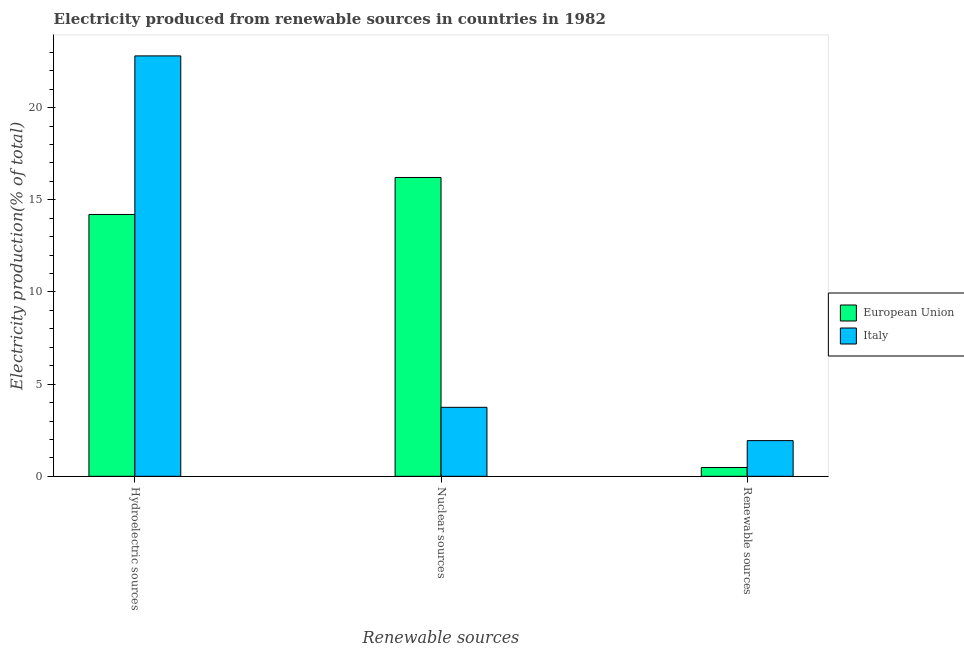How many groups of bars are there?
Give a very brief answer. 3. How many bars are there on the 2nd tick from the left?
Offer a very short reply. 2. How many bars are there on the 1st tick from the right?
Provide a short and direct response. 2. What is the label of the 2nd group of bars from the left?
Your answer should be very brief. Nuclear sources. What is the percentage of electricity produced by nuclear sources in European Union?
Make the answer very short. 16.21. Across all countries, what is the maximum percentage of electricity produced by nuclear sources?
Provide a succinct answer. 16.21. Across all countries, what is the minimum percentage of electricity produced by hydroelectric sources?
Offer a very short reply. 14.2. In which country was the percentage of electricity produced by hydroelectric sources maximum?
Offer a very short reply. Italy. What is the total percentage of electricity produced by hydroelectric sources in the graph?
Keep it short and to the point. 37.01. What is the difference between the percentage of electricity produced by renewable sources in European Union and that in Italy?
Keep it short and to the point. -1.46. What is the difference between the percentage of electricity produced by nuclear sources in Italy and the percentage of electricity produced by renewable sources in European Union?
Provide a short and direct response. 3.26. What is the average percentage of electricity produced by nuclear sources per country?
Provide a short and direct response. 9.98. What is the difference between the percentage of electricity produced by hydroelectric sources and percentage of electricity produced by renewable sources in Italy?
Keep it short and to the point. 20.87. In how many countries, is the percentage of electricity produced by hydroelectric sources greater than 2 %?
Your answer should be compact. 2. What is the ratio of the percentage of electricity produced by hydroelectric sources in European Union to that in Italy?
Make the answer very short. 0.62. Is the percentage of electricity produced by nuclear sources in European Union less than that in Italy?
Ensure brevity in your answer.  No. What is the difference between the highest and the second highest percentage of electricity produced by hydroelectric sources?
Ensure brevity in your answer.  8.6. What is the difference between the highest and the lowest percentage of electricity produced by nuclear sources?
Ensure brevity in your answer.  12.47. In how many countries, is the percentage of electricity produced by renewable sources greater than the average percentage of electricity produced by renewable sources taken over all countries?
Offer a terse response. 1. What does the 2nd bar from the left in Hydroelectric sources represents?
Keep it short and to the point. Italy. What does the 1st bar from the right in Renewable sources represents?
Your response must be concise. Italy. Is it the case that in every country, the sum of the percentage of electricity produced by hydroelectric sources and percentage of electricity produced by nuclear sources is greater than the percentage of electricity produced by renewable sources?
Your response must be concise. Yes. How many countries are there in the graph?
Provide a short and direct response. 2. What is the difference between two consecutive major ticks on the Y-axis?
Ensure brevity in your answer.  5. Does the graph contain grids?
Provide a short and direct response. No. What is the title of the graph?
Give a very brief answer. Electricity produced from renewable sources in countries in 1982. Does "Sudan" appear as one of the legend labels in the graph?
Offer a terse response. No. What is the label or title of the X-axis?
Provide a succinct answer. Renewable sources. What is the Electricity production(% of total) of European Union in Hydroelectric sources?
Offer a very short reply. 14.2. What is the Electricity production(% of total) in Italy in Hydroelectric sources?
Your response must be concise. 22.8. What is the Electricity production(% of total) in European Union in Nuclear sources?
Keep it short and to the point. 16.21. What is the Electricity production(% of total) of Italy in Nuclear sources?
Provide a short and direct response. 3.74. What is the Electricity production(% of total) of European Union in Renewable sources?
Offer a very short reply. 0.48. What is the Electricity production(% of total) in Italy in Renewable sources?
Give a very brief answer. 1.94. Across all Renewable sources, what is the maximum Electricity production(% of total) of European Union?
Offer a very short reply. 16.21. Across all Renewable sources, what is the maximum Electricity production(% of total) of Italy?
Your answer should be very brief. 22.8. Across all Renewable sources, what is the minimum Electricity production(% of total) of European Union?
Provide a succinct answer. 0.48. Across all Renewable sources, what is the minimum Electricity production(% of total) of Italy?
Your response must be concise. 1.94. What is the total Electricity production(% of total) in European Union in the graph?
Your answer should be very brief. 30.89. What is the total Electricity production(% of total) of Italy in the graph?
Your response must be concise. 28.48. What is the difference between the Electricity production(% of total) of European Union in Hydroelectric sources and that in Nuclear sources?
Your response must be concise. -2.01. What is the difference between the Electricity production(% of total) of Italy in Hydroelectric sources and that in Nuclear sources?
Give a very brief answer. 19.06. What is the difference between the Electricity production(% of total) in European Union in Hydroelectric sources and that in Renewable sources?
Provide a short and direct response. 13.72. What is the difference between the Electricity production(% of total) in Italy in Hydroelectric sources and that in Renewable sources?
Make the answer very short. 20.87. What is the difference between the Electricity production(% of total) in European Union in Nuclear sources and that in Renewable sources?
Ensure brevity in your answer.  15.73. What is the difference between the Electricity production(% of total) of Italy in Nuclear sources and that in Renewable sources?
Provide a succinct answer. 1.81. What is the difference between the Electricity production(% of total) in European Union in Hydroelectric sources and the Electricity production(% of total) in Italy in Nuclear sources?
Ensure brevity in your answer.  10.46. What is the difference between the Electricity production(% of total) in European Union in Hydroelectric sources and the Electricity production(% of total) in Italy in Renewable sources?
Your answer should be very brief. 12.27. What is the difference between the Electricity production(% of total) of European Union in Nuclear sources and the Electricity production(% of total) of Italy in Renewable sources?
Ensure brevity in your answer.  14.27. What is the average Electricity production(% of total) in European Union per Renewable sources?
Make the answer very short. 10.3. What is the average Electricity production(% of total) of Italy per Renewable sources?
Provide a succinct answer. 9.49. What is the difference between the Electricity production(% of total) of European Union and Electricity production(% of total) of Italy in Hydroelectric sources?
Provide a succinct answer. -8.6. What is the difference between the Electricity production(% of total) in European Union and Electricity production(% of total) in Italy in Nuclear sources?
Keep it short and to the point. 12.47. What is the difference between the Electricity production(% of total) in European Union and Electricity production(% of total) in Italy in Renewable sources?
Provide a succinct answer. -1.46. What is the ratio of the Electricity production(% of total) of European Union in Hydroelectric sources to that in Nuclear sources?
Make the answer very short. 0.88. What is the ratio of the Electricity production(% of total) of Italy in Hydroelectric sources to that in Nuclear sources?
Give a very brief answer. 6.09. What is the ratio of the Electricity production(% of total) of European Union in Hydroelectric sources to that in Renewable sources?
Your response must be concise. 29.66. What is the ratio of the Electricity production(% of total) in Italy in Hydroelectric sources to that in Renewable sources?
Your answer should be compact. 11.78. What is the ratio of the Electricity production(% of total) of European Union in Nuclear sources to that in Renewable sources?
Your answer should be compact. 33.84. What is the ratio of the Electricity production(% of total) of Italy in Nuclear sources to that in Renewable sources?
Offer a very short reply. 1.93. What is the difference between the highest and the second highest Electricity production(% of total) in European Union?
Offer a terse response. 2.01. What is the difference between the highest and the second highest Electricity production(% of total) in Italy?
Your answer should be compact. 19.06. What is the difference between the highest and the lowest Electricity production(% of total) of European Union?
Provide a short and direct response. 15.73. What is the difference between the highest and the lowest Electricity production(% of total) in Italy?
Make the answer very short. 20.87. 